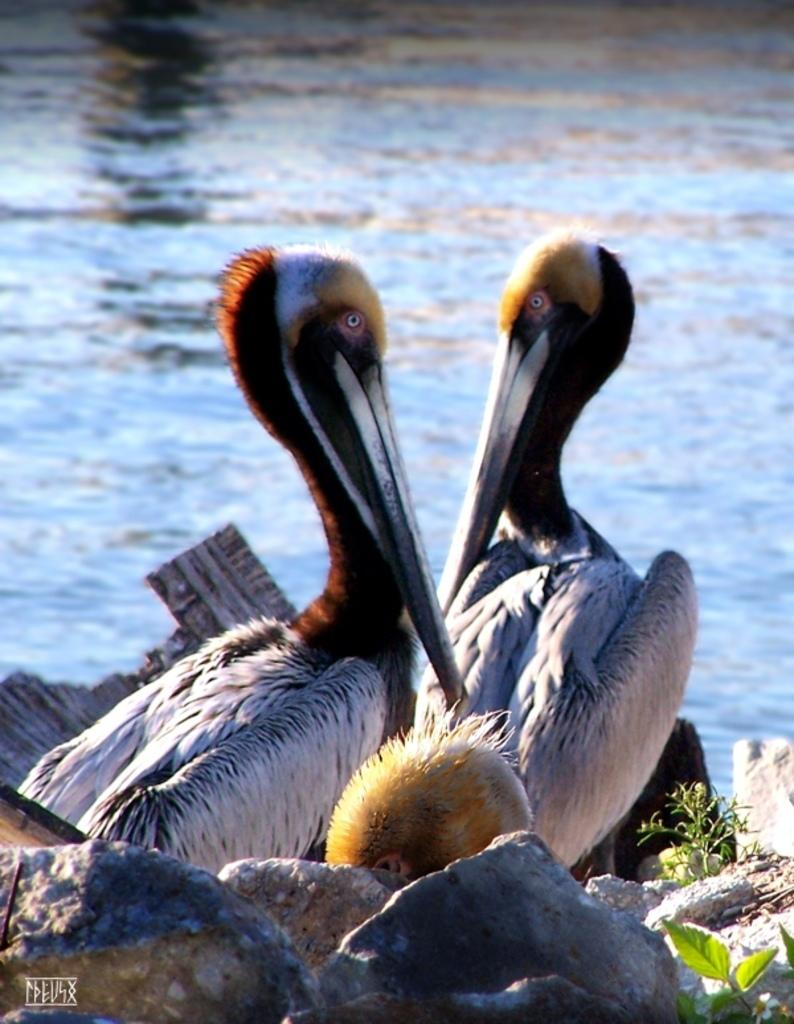What type of animals can be seen in the image? There are birds in the image. What other objects or elements can be seen in the image? There are stones and plants visible in the image. What can be seen in the background of the image? There is water visible in the background of the image. What type of printing error can be seen on the stones in the image? There is no printing error present in the image, as the stones are natural objects and not printed materials. 